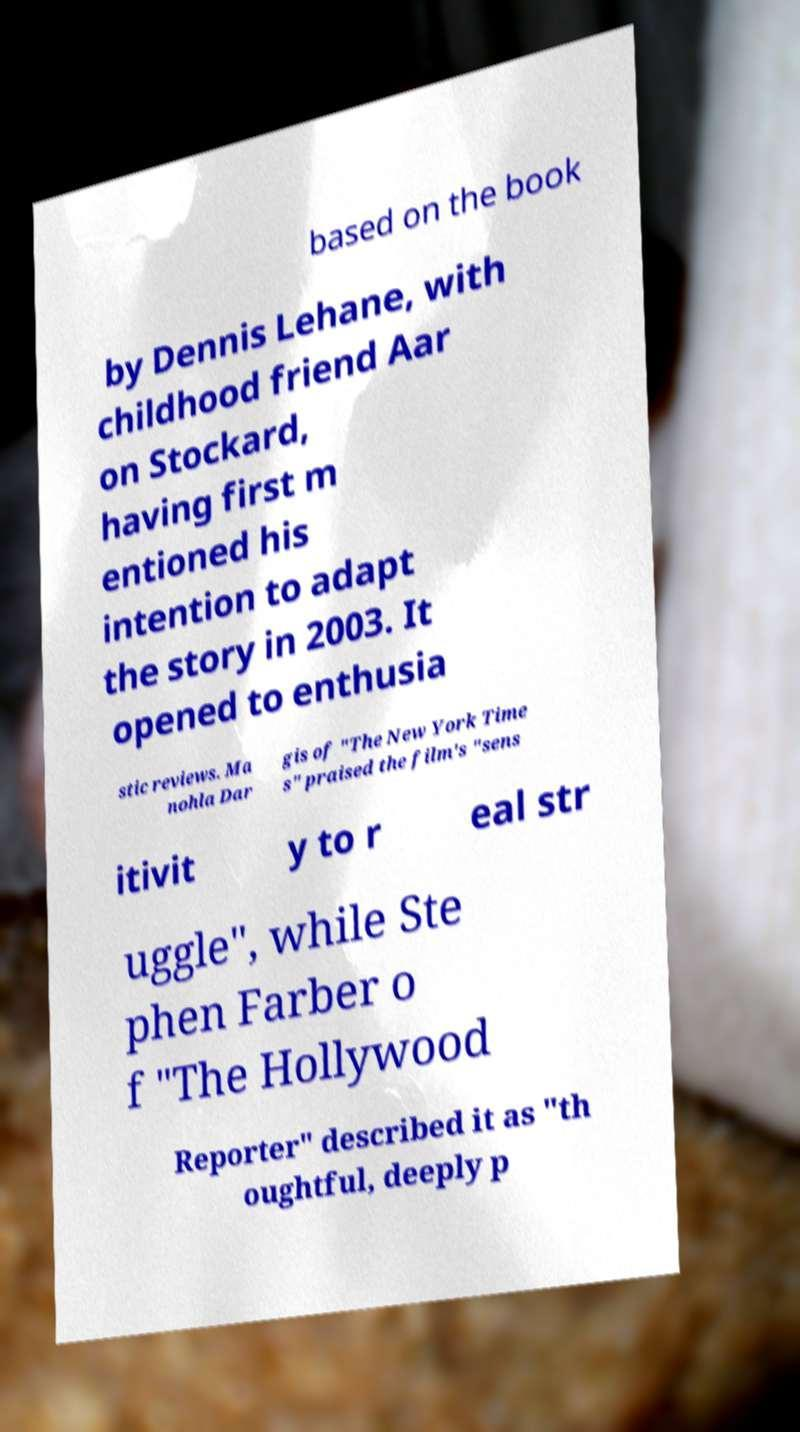Can you accurately transcribe the text from the provided image for me? based on the book by Dennis Lehane, with childhood friend Aar on Stockard, having first m entioned his intention to adapt the story in 2003. It opened to enthusia stic reviews. Ma nohla Dar gis of "The New York Time s" praised the film's "sens itivit y to r eal str uggle", while Ste phen Farber o f "The Hollywood Reporter" described it as "th oughtful, deeply p 